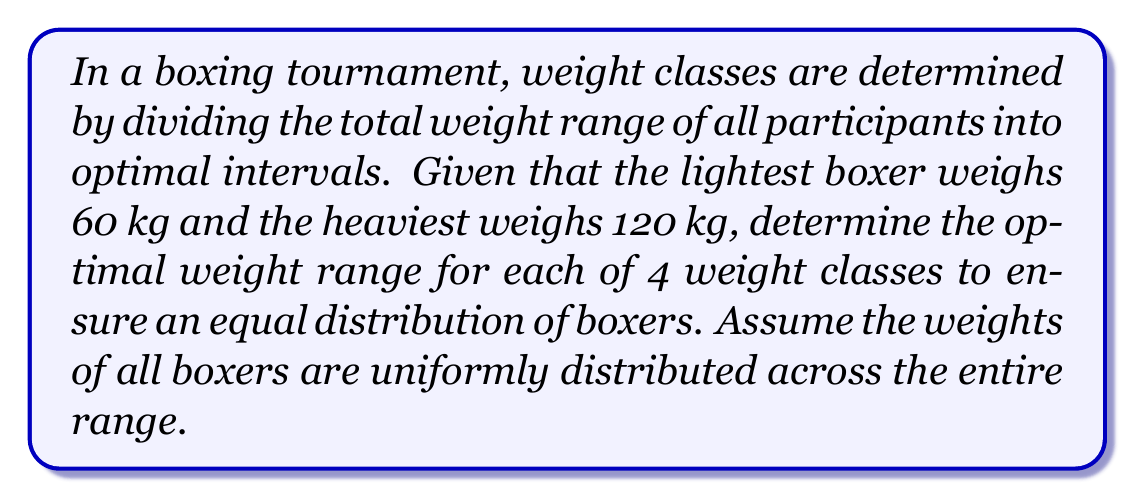Teach me how to tackle this problem. To solve this problem, we need to divide the total weight range into 4 equal intervals. This will ensure an optimal distribution of boxers across weight classes.

1. Calculate the total weight range:
   $$ \text{Total range} = 120 \text{ kg} - 60 \text{ kg} = 60 \text{ kg} $$

2. Divide the total range by the number of weight classes:
   $$ \text{Weight range per class} = \frac{60 \text{ kg}}{4} = 15 \text{ kg} $$

3. Calculate the boundaries for each weight class:
   - Class 1: 60 kg to 75 kg
   - Class 2: 75 kg to 90 kg
   - Class 3: 90 kg to 105 kg
   - Class 4: 105 kg to 120 kg

4. Express the weight ranges mathematically:
   Let $w$ be the weight of a boxer in kg.
   - Class 1: $60 \leq w < 75$
   - Class 2: $75 \leq w < 90$
   - Class 3: $90 \leq w < 105$
   - Class 4: $105 \leq w \leq 120$

This division ensures that each weight class has an equal range of 15 kg, optimizing the distribution of boxers across classes assuming a uniform distribution of weights.
Answer: The optimal weight ranges for the 4 weight classes are:
Class 1: $[60, 75)$ kg
Class 2: $[75, 90)$ kg
Class 3: $[90, 105)$ kg
Class 4: $[105, 120]$ kg
Each class has a range of 15 kg. 